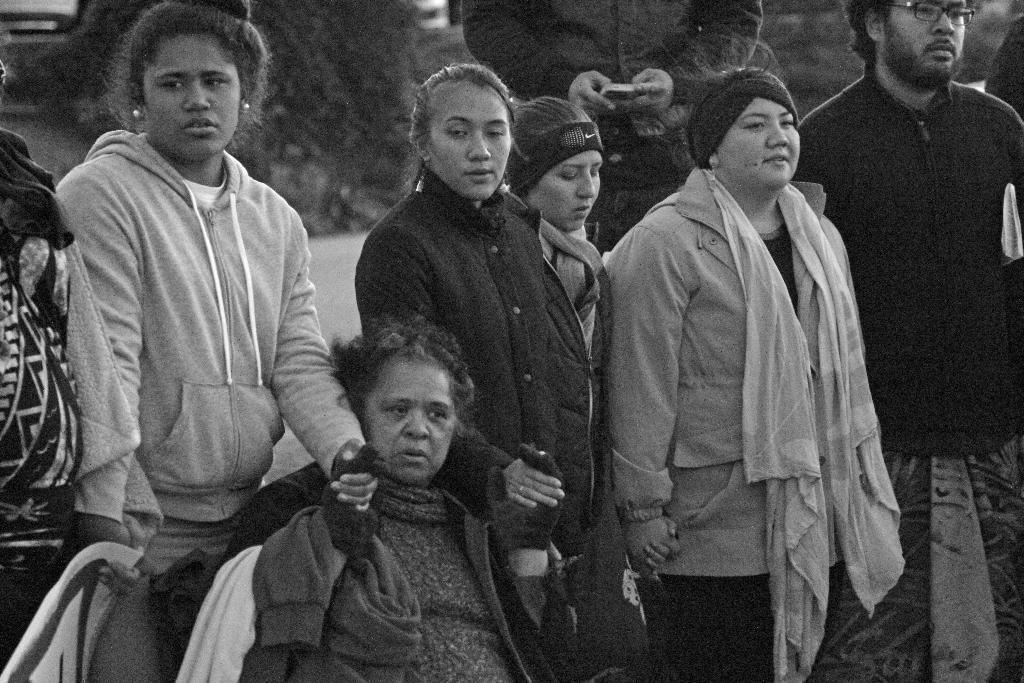What is the color scheme of the image? The image is black and white. What can be seen in the image? There are people in the image. What are the people doing in the image? The people are standing and holding hands of each other. What type of apple can be seen in the image? There is no apple present in the image. What event is taking place in the image? The provided facts do not mention any specific event occurring in the image. 